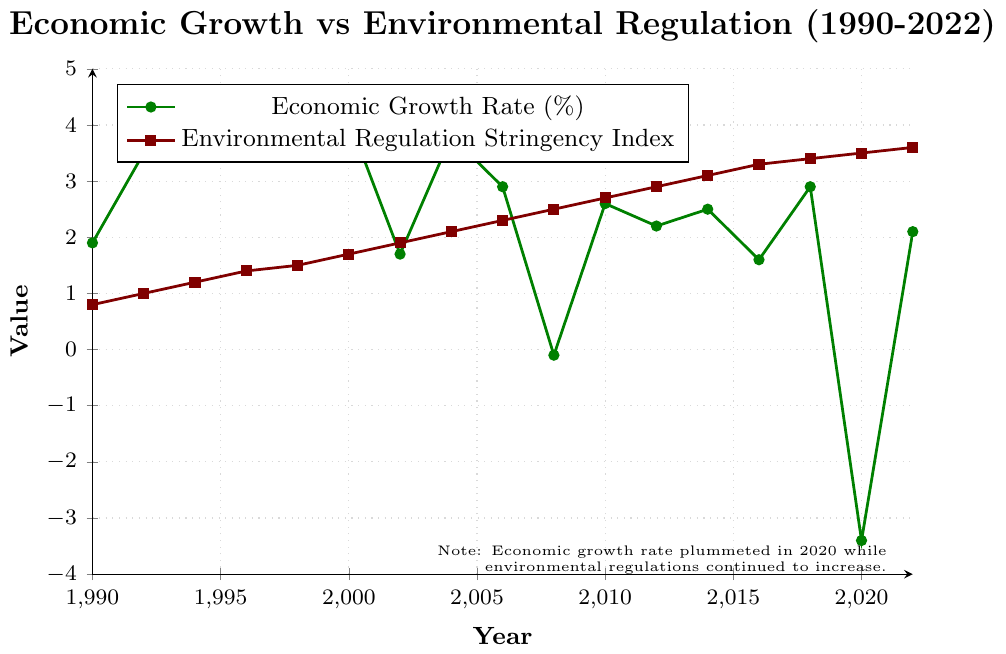How did the economic growth rate in 2020 compare to the previous year? In 2018, the economic growth rate was 2.9%, and in 2020 it dropped to -3.4%, indicating a significant decline.
Answer: It decreased significantly How does the economic growth rate in 2022 compare to that in 1990? The economic growth rate in 2022 was 2.1%, while in 1990 it was 1.9%, indicating a slight increase over the 32-year period.
Answer: It increased slightly What trend is observed in the Environmental Regulation Stringency Index from 1990 to 2022? The Environmental Regulation Stringency Index steadily increased from 0.8 in 1990 to 3.6 in 2022.
Answer: It increased steadily At which points did the economic growth rate drop below 0%? The economic growth rate dropped below 0% in 2008 (-0.1%) and in 2020 (-3.4%).
Answer: 2008 and 2020 Compare the economic growth rates between 1998 and 2008. In 1998, the economic growth rate was 4.5%, while in 2008, it was -0.1%, indicating a significant decrease.
Answer: It significantly decreased What is the difference between the economic growth rate and the Environmental Regulation Stringency Index in 1990? In 1990, the economic growth rate was 1.9% and the Environmental Regulation Stringency Index was 0.8, so the difference is 1.9 - 0.8 = 1.1.
Answer: 1.1 What is the average economic growth rate during the 2000s? The economic growth rates for the years 2000, 2002, 2004, 2006, and 2008 are 4.1%, 1.7%, 3.8%, 2.9%, and -0.1%, respectively. The average is (4.1 + 1.7 + 3.8 + 2.9 - 0.1) / 5 = 2.48%.
Answer: 2.48 By how much did the Environmental Regulation Stringency Index increase between 1990 and 2022? In 1990, the index was 0.8, and in 2022 it was 3.6. The increase is 3.6 - 0.8 = 2.8.
Answer: 2.8 